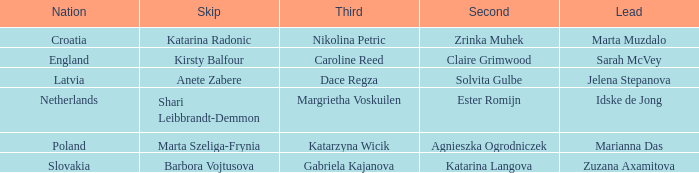Who holds the second position with nikolina petric in the third spot? Zrinka Muhek. 